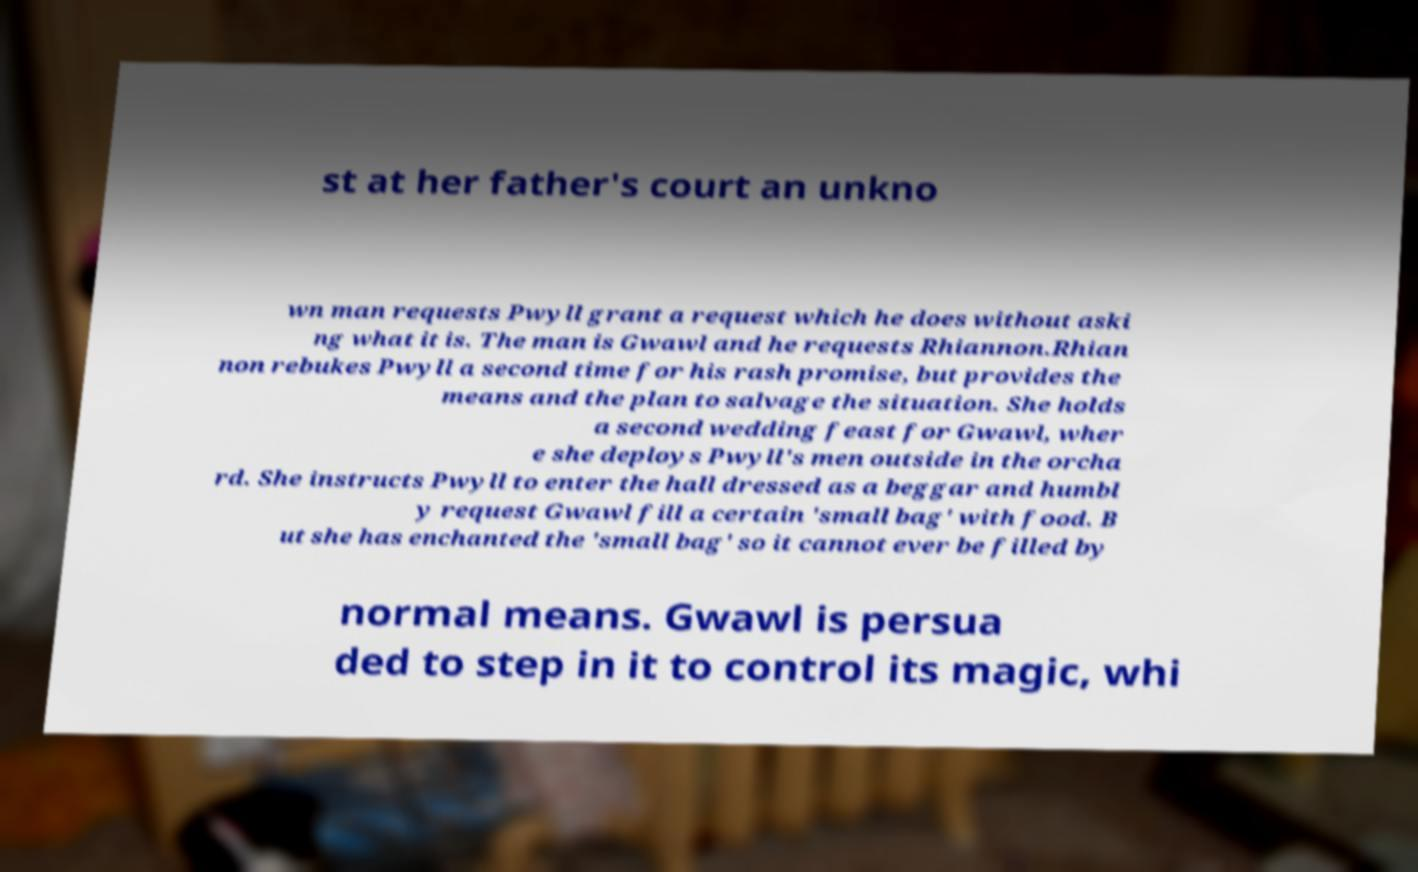For documentation purposes, I need the text within this image transcribed. Could you provide that? st at her father's court an unkno wn man requests Pwyll grant a request which he does without aski ng what it is. The man is Gwawl and he requests Rhiannon.Rhian non rebukes Pwyll a second time for his rash promise, but provides the means and the plan to salvage the situation. She holds a second wedding feast for Gwawl, wher e she deploys Pwyll's men outside in the orcha rd. She instructs Pwyll to enter the hall dressed as a beggar and humbl y request Gwawl fill a certain 'small bag' with food. B ut she has enchanted the 'small bag' so it cannot ever be filled by normal means. Gwawl is persua ded to step in it to control its magic, whi 